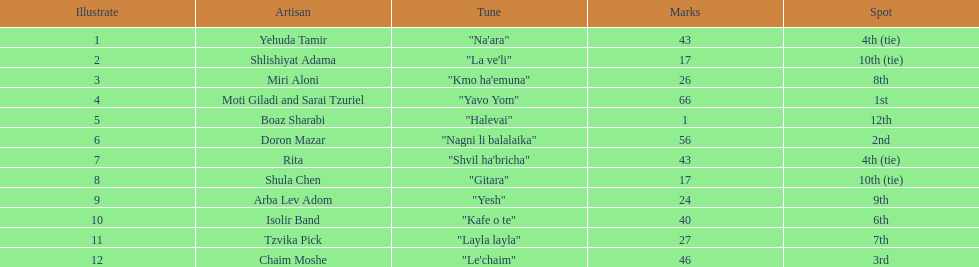What song is listed in the table right before layla layla? "Kafe o te". 